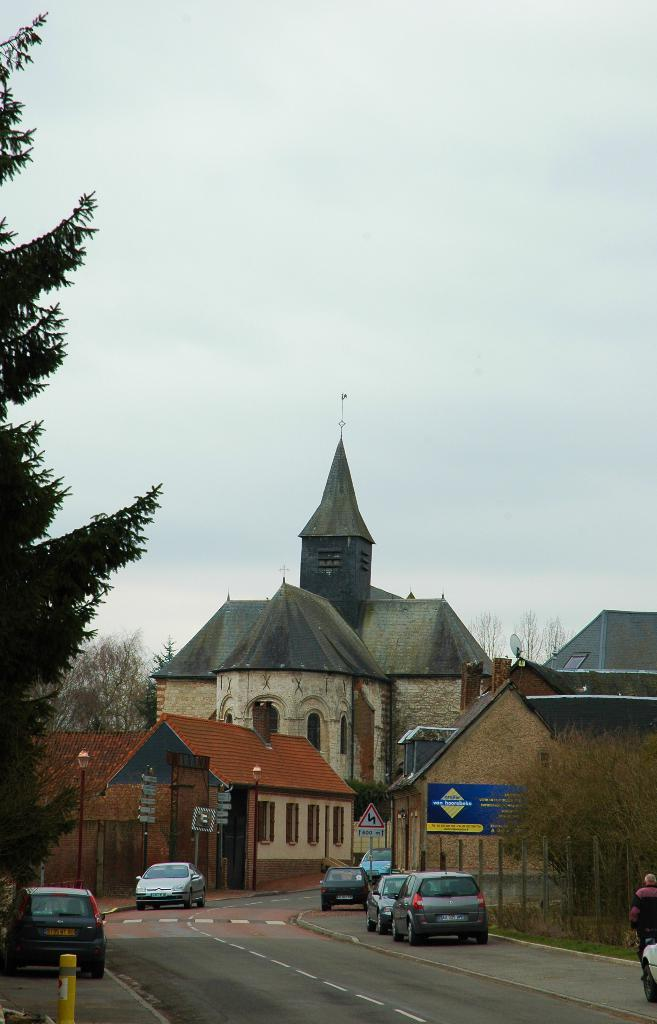What can be seen at the bottom of the image? There are vehicles, roads, trees, poles, a banner, sign boards, houses, and a person at the bottom of the image. What type of structures are present at the bottom of the image? Houses are present at the bottom of the image. What is the person at the bottom of the image doing? The provided facts do not specify what the person is doing. What is visible in the background of the image? The sky is visible in the background of the image. How many brothers are depicted in the science experiment in the image? There is no science experiment or brothers present in the image. What type of sound can be heard coming from the sign boards in the image? Sign boards do not produce sound, so there is no sound to be heard from them in the image. 